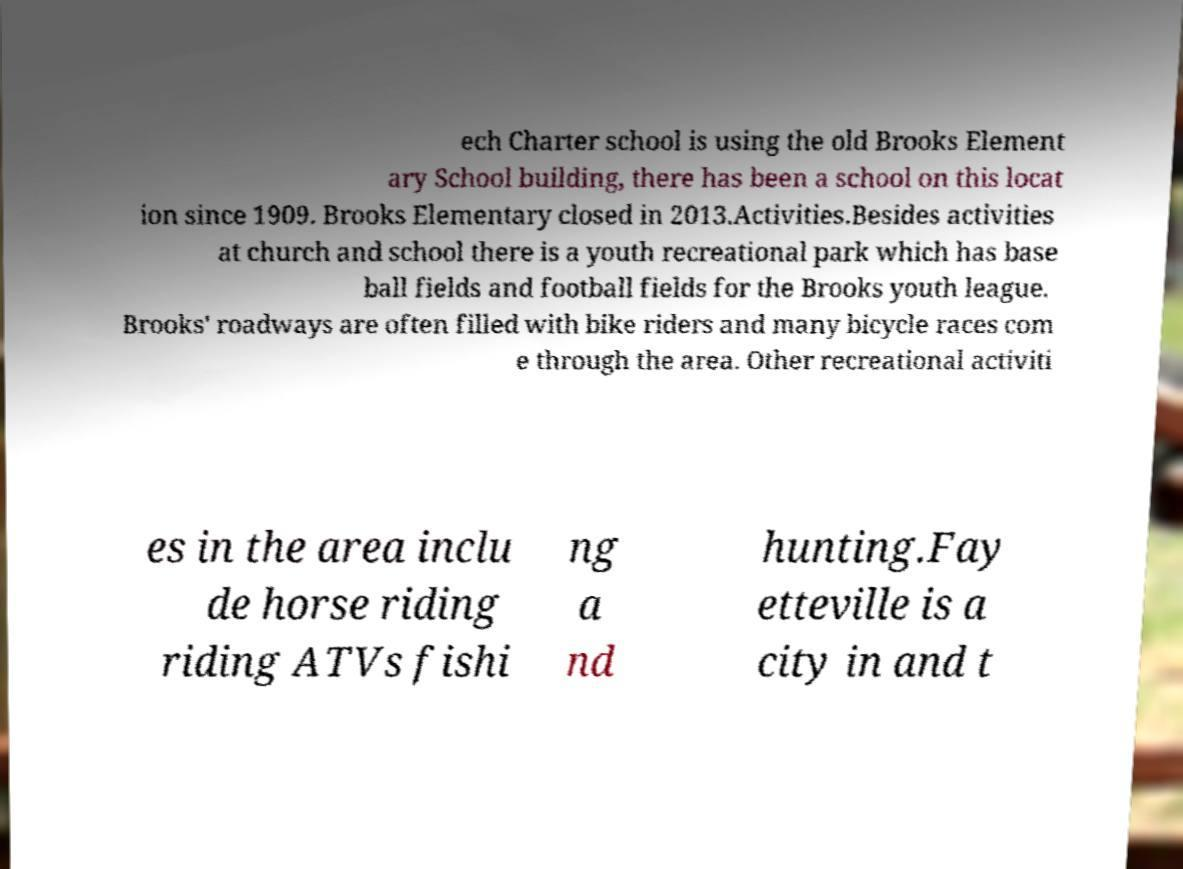For documentation purposes, I need the text within this image transcribed. Could you provide that? ech Charter school is using the old Brooks Element ary School building, there has been a school on this locat ion since 1909. Brooks Elementary closed in 2013.Activities.Besides activities at church and school there is a youth recreational park which has base ball fields and football fields for the Brooks youth league. Brooks' roadways are often filled with bike riders and many bicycle races com e through the area. Other recreational activiti es in the area inclu de horse riding riding ATVs fishi ng a nd hunting.Fay etteville is a city in and t 